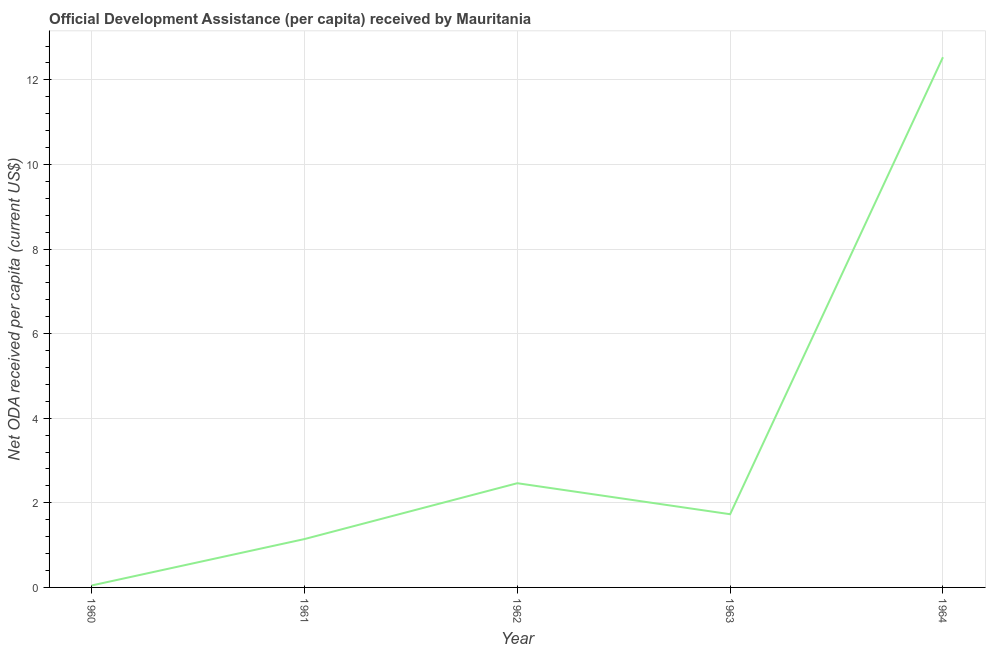What is the net oda received per capita in 1964?
Provide a succinct answer. 12.53. Across all years, what is the maximum net oda received per capita?
Your answer should be very brief. 12.53. Across all years, what is the minimum net oda received per capita?
Offer a very short reply. 0.05. In which year was the net oda received per capita maximum?
Ensure brevity in your answer.  1964. In which year was the net oda received per capita minimum?
Provide a succinct answer. 1960. What is the sum of the net oda received per capita?
Keep it short and to the point. 17.92. What is the difference between the net oda received per capita in 1960 and 1963?
Your answer should be very brief. -1.68. What is the average net oda received per capita per year?
Your response must be concise. 3.58. What is the median net oda received per capita?
Make the answer very short. 1.73. What is the ratio of the net oda received per capita in 1961 to that in 1964?
Offer a terse response. 0.09. Is the net oda received per capita in 1961 less than that in 1963?
Provide a short and direct response. Yes. What is the difference between the highest and the second highest net oda received per capita?
Your response must be concise. 10.07. Is the sum of the net oda received per capita in 1962 and 1964 greater than the maximum net oda received per capita across all years?
Your response must be concise. Yes. What is the difference between the highest and the lowest net oda received per capita?
Ensure brevity in your answer.  12.49. In how many years, is the net oda received per capita greater than the average net oda received per capita taken over all years?
Offer a very short reply. 1. How many lines are there?
Provide a short and direct response. 1. Are the values on the major ticks of Y-axis written in scientific E-notation?
Provide a succinct answer. No. Does the graph contain any zero values?
Provide a succinct answer. No. Does the graph contain grids?
Your answer should be very brief. Yes. What is the title of the graph?
Your response must be concise. Official Development Assistance (per capita) received by Mauritania. What is the label or title of the X-axis?
Your response must be concise. Year. What is the label or title of the Y-axis?
Offer a terse response. Net ODA received per capita (current US$). What is the Net ODA received per capita (current US$) in 1960?
Your answer should be very brief. 0.05. What is the Net ODA received per capita (current US$) in 1961?
Offer a very short reply. 1.14. What is the Net ODA received per capita (current US$) in 1962?
Give a very brief answer. 2.46. What is the Net ODA received per capita (current US$) in 1963?
Ensure brevity in your answer.  1.73. What is the Net ODA received per capita (current US$) of 1964?
Your response must be concise. 12.53. What is the difference between the Net ODA received per capita (current US$) in 1960 and 1961?
Your response must be concise. -1.1. What is the difference between the Net ODA received per capita (current US$) in 1960 and 1962?
Give a very brief answer. -2.42. What is the difference between the Net ODA received per capita (current US$) in 1960 and 1963?
Offer a very short reply. -1.68. What is the difference between the Net ODA received per capita (current US$) in 1960 and 1964?
Ensure brevity in your answer.  -12.49. What is the difference between the Net ODA received per capita (current US$) in 1961 and 1962?
Offer a terse response. -1.32. What is the difference between the Net ODA received per capita (current US$) in 1961 and 1963?
Ensure brevity in your answer.  -0.59. What is the difference between the Net ODA received per capita (current US$) in 1961 and 1964?
Your answer should be compact. -11.39. What is the difference between the Net ODA received per capita (current US$) in 1962 and 1963?
Offer a terse response. 0.73. What is the difference between the Net ODA received per capita (current US$) in 1962 and 1964?
Offer a terse response. -10.07. What is the difference between the Net ODA received per capita (current US$) in 1963 and 1964?
Offer a very short reply. -10.8. What is the ratio of the Net ODA received per capita (current US$) in 1960 to that in 1961?
Your answer should be very brief. 0.04. What is the ratio of the Net ODA received per capita (current US$) in 1960 to that in 1962?
Give a very brief answer. 0.02. What is the ratio of the Net ODA received per capita (current US$) in 1960 to that in 1963?
Offer a very short reply. 0.03. What is the ratio of the Net ODA received per capita (current US$) in 1960 to that in 1964?
Offer a very short reply. 0. What is the ratio of the Net ODA received per capita (current US$) in 1961 to that in 1962?
Offer a very short reply. 0.46. What is the ratio of the Net ODA received per capita (current US$) in 1961 to that in 1963?
Keep it short and to the point. 0.66. What is the ratio of the Net ODA received per capita (current US$) in 1961 to that in 1964?
Your response must be concise. 0.09. What is the ratio of the Net ODA received per capita (current US$) in 1962 to that in 1963?
Provide a short and direct response. 1.42. What is the ratio of the Net ODA received per capita (current US$) in 1962 to that in 1964?
Your answer should be compact. 0.2. What is the ratio of the Net ODA received per capita (current US$) in 1963 to that in 1964?
Offer a terse response. 0.14. 